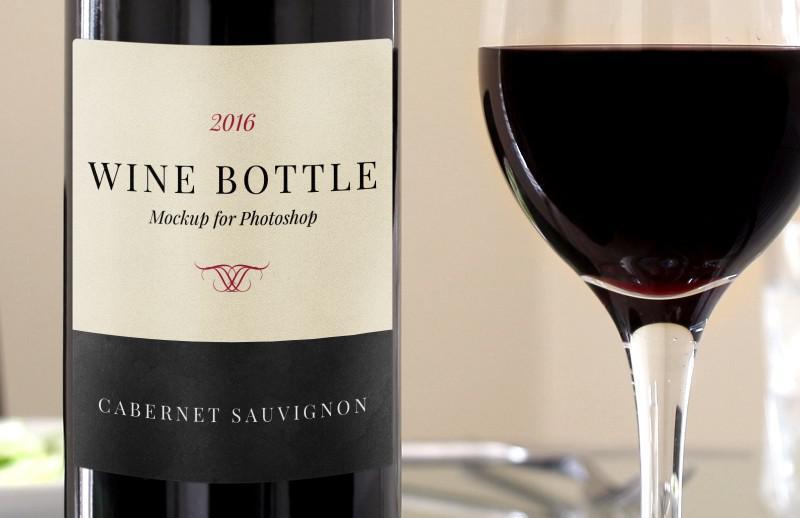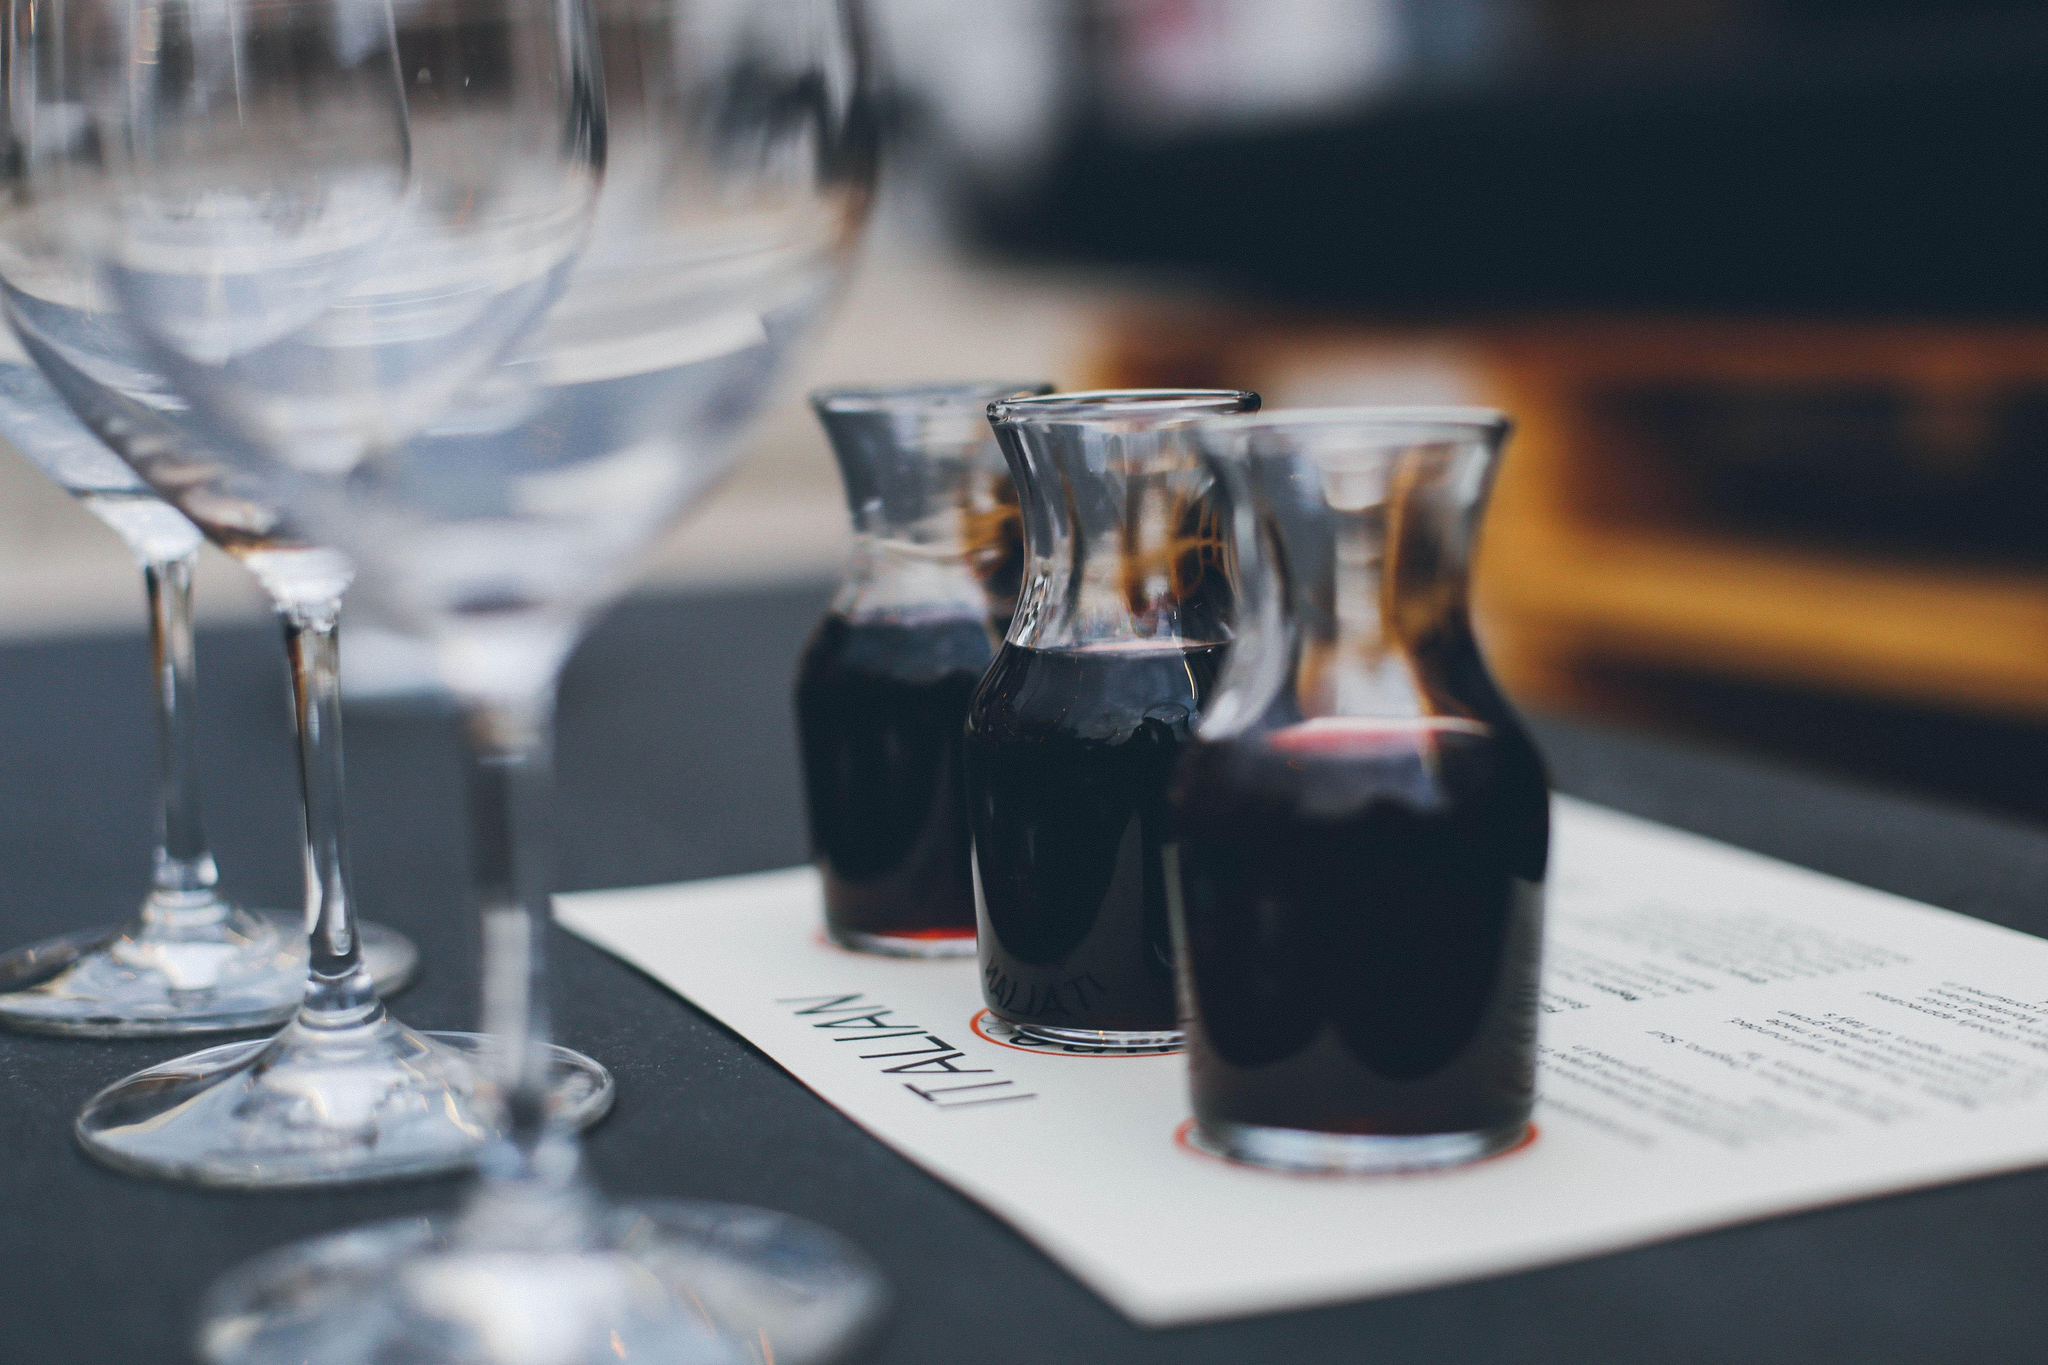The first image is the image on the left, the second image is the image on the right. Given the left and right images, does the statement "There is more than one wine glass in one of the images." hold true? Answer yes or no. Yes. 